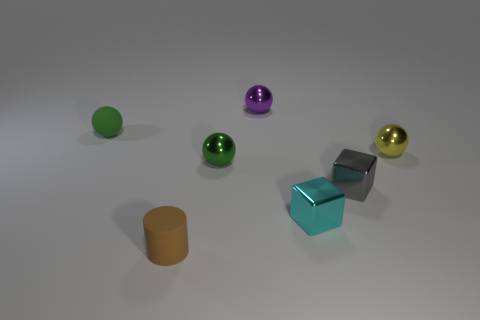What number of other things are the same color as the rubber cylinder?
Provide a succinct answer. 0. Is the shape of the tiny matte thing behind the yellow sphere the same as the matte thing in front of the matte ball?
Give a very brief answer. No. How many objects are tiny objects that are to the right of the cyan shiny thing or small things behind the cylinder?
Give a very brief answer. 6. What number of other things are there of the same material as the tiny yellow object
Keep it short and to the point. 4. Do the small green sphere in front of the green rubber object and the tiny purple thing have the same material?
Give a very brief answer. Yes. Is the number of small purple metallic spheres in front of the tiny purple thing greater than the number of tiny brown matte cylinders right of the tiny cyan metal thing?
Provide a succinct answer. No. How many objects are either objects on the right side of the small green matte sphere or small gray blocks?
Your answer should be compact. 6. What shape is the cyan object that is the same material as the gray block?
Provide a short and direct response. Cube. Is there anything else that is the same shape as the small cyan metal thing?
Provide a succinct answer. Yes. What is the color of the small thing that is both in front of the gray shiny thing and on the right side of the brown cylinder?
Provide a succinct answer. Cyan. 